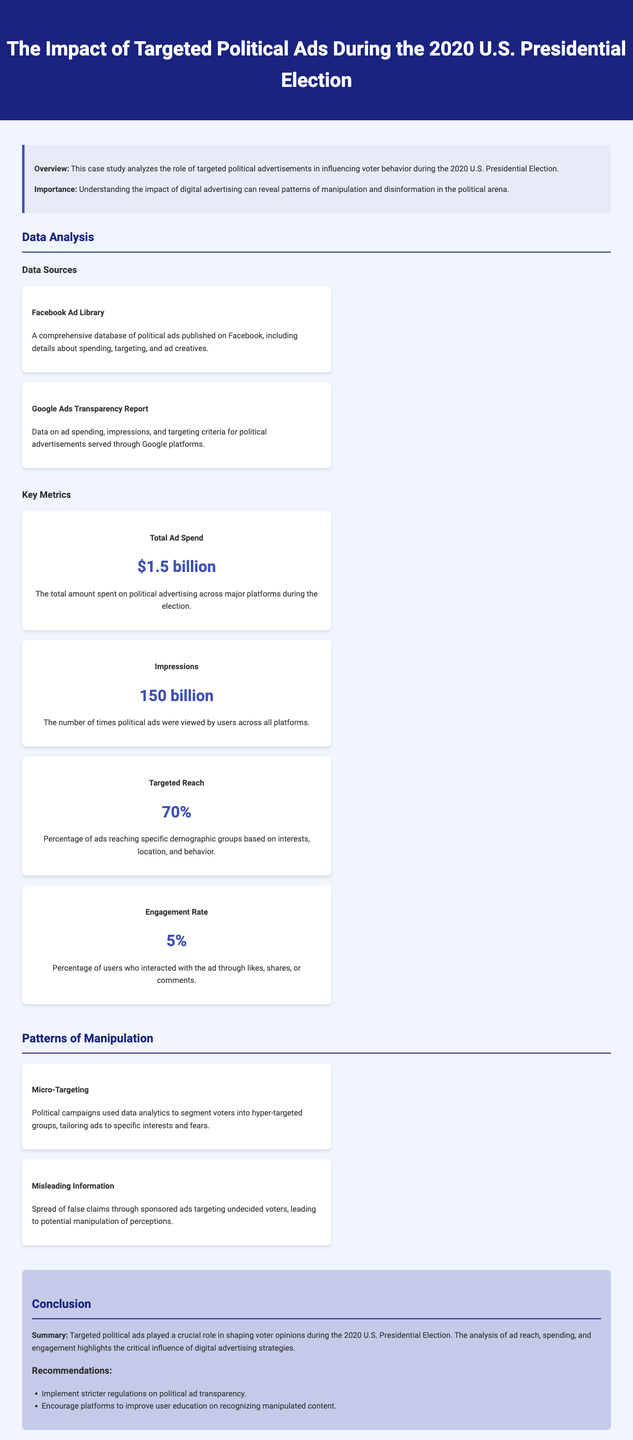what is the total ad spend during the election? The document states the total amount spent on political advertising across major platforms during the election is $1.5 billion.
Answer: $1.5 billion what percentage of ads reached specific demographic groups? The document mentions that 70% of ads were targeted towards specific demographic groups based on interests, location, and behavior.
Answer: 70% what was the engagement rate for political ads? The engagement rate, as noted in the document, is the percentage of users who interacted with the ad through likes, shares, or comments, which is 5%.
Answer: 5% what is one method of manipulation mentioned in the study? The document highlights "Micro-Targeting" as one of the methods used by political campaigns to manipulate voter perception.
Answer: Micro-Targeting how many impressions did political ads receive? According to the document, political ads were viewed 150 billion times across all platforms.
Answer: 150 billion what are the two major data sources mentioned? The document lists "Facebook Ad Library" and "Google Ads Transparency Report" as the major sources of data used in the study.
Answer: Facebook Ad Library, Google Ads Transparency Report what is the summary of the impact of targeted political ads? The document summarizes that targeted political ads played a crucial role in shaping voter opinions during the election.
Answer: Crucial role in shaping voter opinions what does the document recommend regarding political ad transparency? The document recommends implementing stricter regulations on political ad transparency.
Answer: Stricter regulations on political ad transparency 